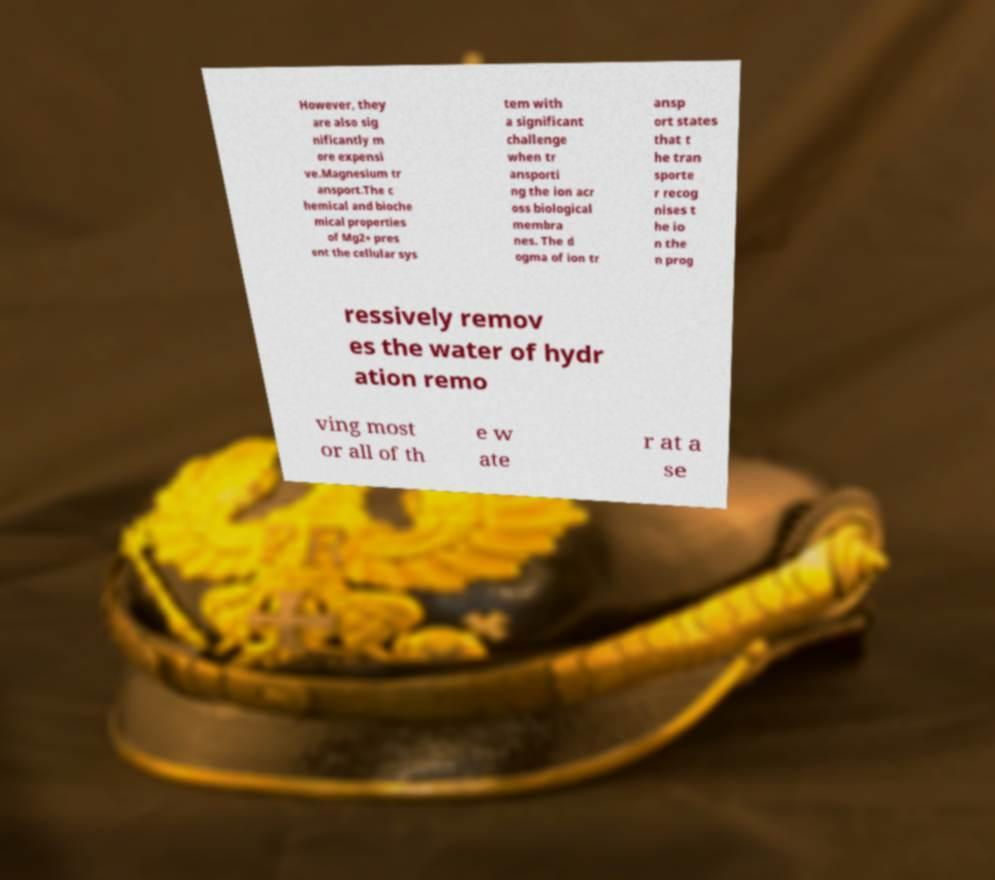What messages or text are displayed in this image? I need them in a readable, typed format. However, they are also sig nificantly m ore expensi ve.Magnesium tr ansport.The c hemical and bioche mical properties of Mg2+ pres ent the cellular sys tem with a significant challenge when tr ansporti ng the ion acr oss biological membra nes. The d ogma of ion tr ansp ort states that t he tran sporte r recog nises t he io n the n prog ressively remov es the water of hydr ation remo ving most or all of th e w ate r at a se 